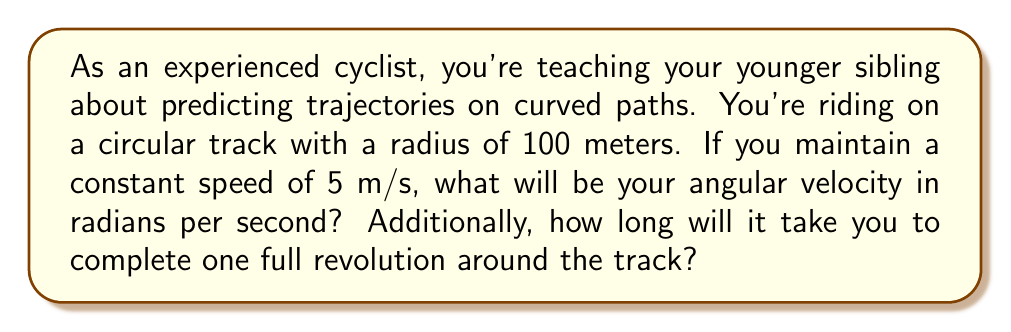Help me with this question. To solve this problem, we need to understand the relationship between linear velocity, angular velocity, and the radius of the circular path. We'll break this down step-by-step:

1. Relationship between linear velocity and angular velocity:
   The formula relating linear velocity ($v$), angular velocity ($\omega$), and radius ($r$) is:
   
   $$v = \omega r$$

2. Calculating angular velocity:
   We can rearrange the formula to solve for $\omega$:
   
   $$\omega = \frac{v}{r}$$
   
   Plugging in our known values:
   $$\omega = \frac{5 \text{ m/s}}{100 \text{ m}} = 0.05 \text{ rad/s}$$

3. Calculating time for one revolution:
   One revolution corresponds to an angle of $2\pi$ radians. We can use the formula:
   
   $$\text{Time} = \frac{\text{Angle}}{\text{Angular Velocity}}$$
   
   $$\text{Time} = \frac{2\pi}{\omega} = \frac{2\pi}{0.05} = 40\pi \approx 125.66 \text{ seconds}$$

[asy]
unitsize(1cm);
draw(circle((0,0),3));
draw((0,0)--(3,0),arrow=Arrow(TeXHead));
label("100 m", (1.5,0), S);
label("5 m/s", (3,0), NE);
dot((0,0));
[/asy]
Answer: The angular velocity is 0.05 rad/s, and it will take approximately 125.66 seconds to complete one full revolution. 